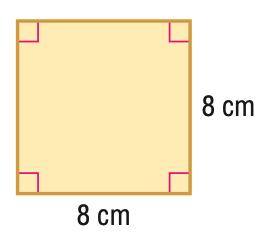Answer the mathemtical geometry problem and directly provide the correct option letter.
Question: Find the perimeter of the figure.
Choices: A: 8 B: 16 C: 32 D: 64 C 